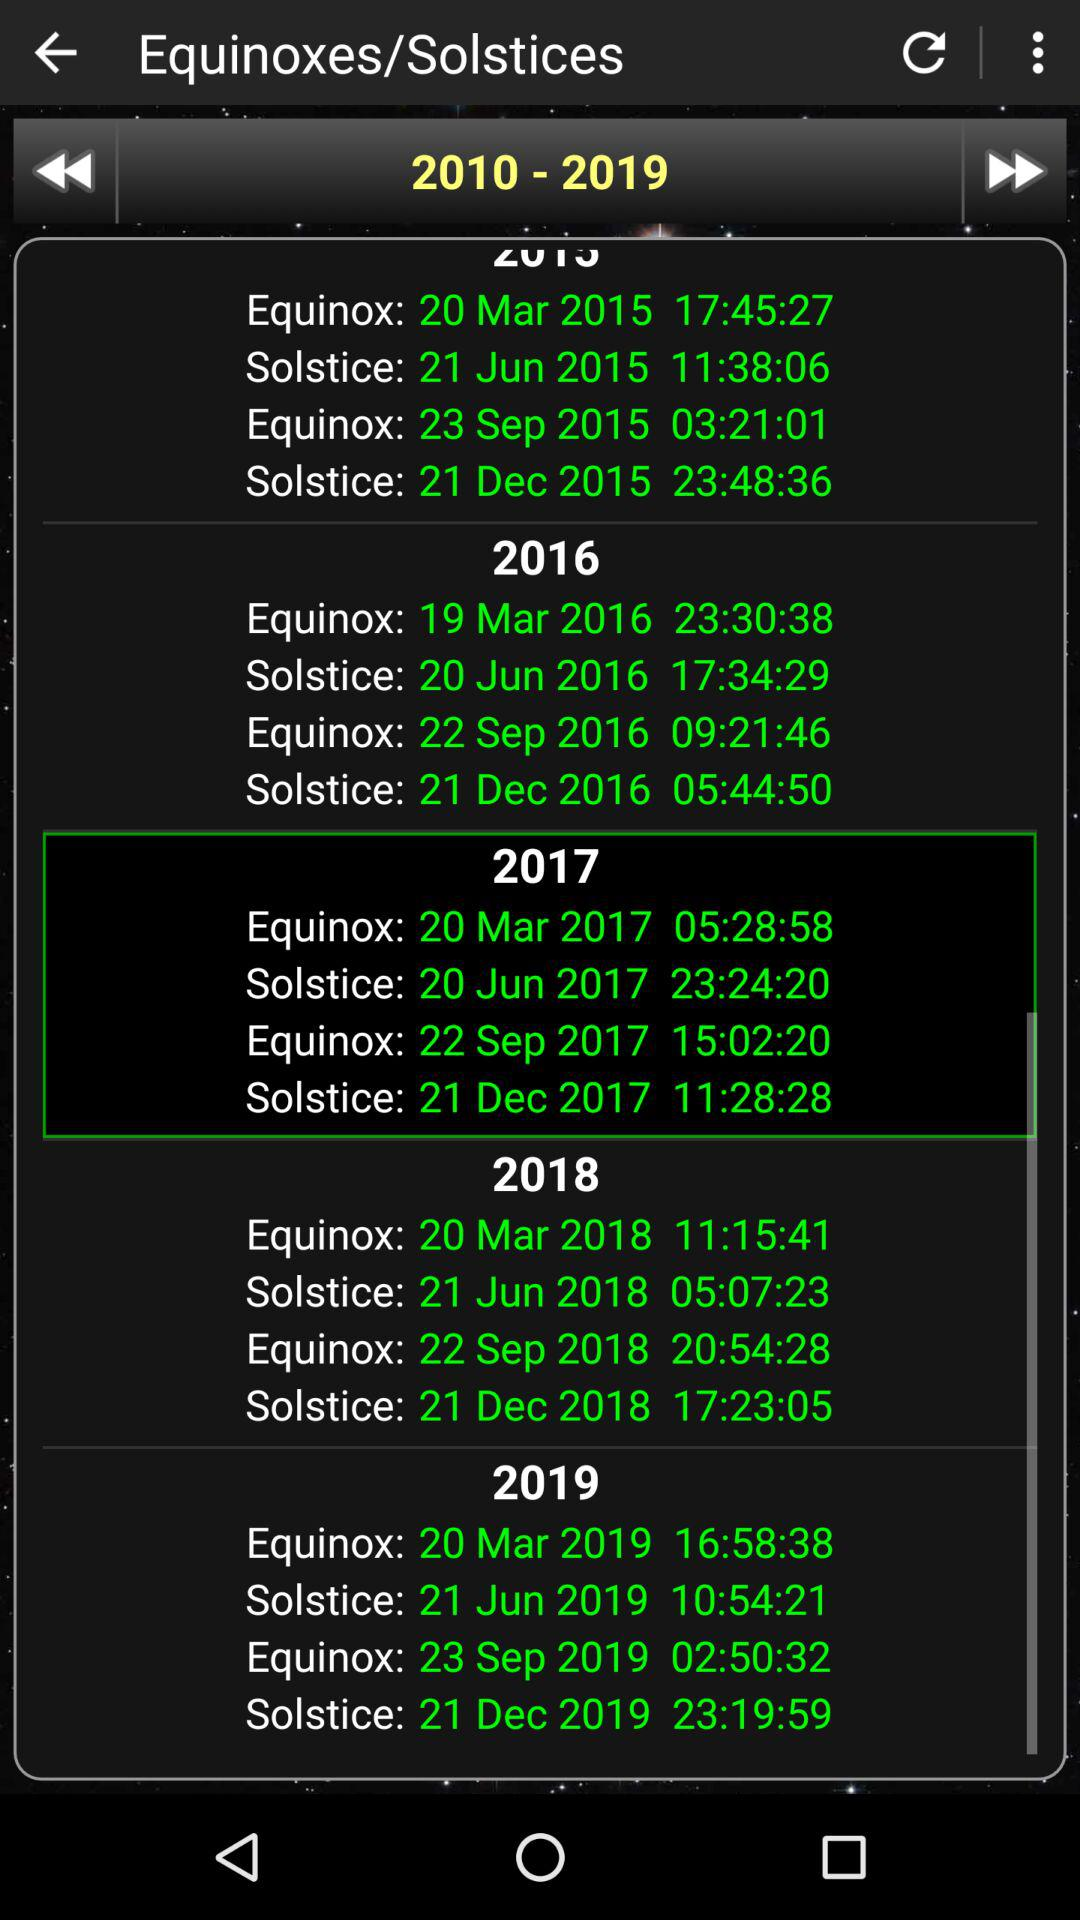What is the selected year? The selected years are from 2010 to 2019. 